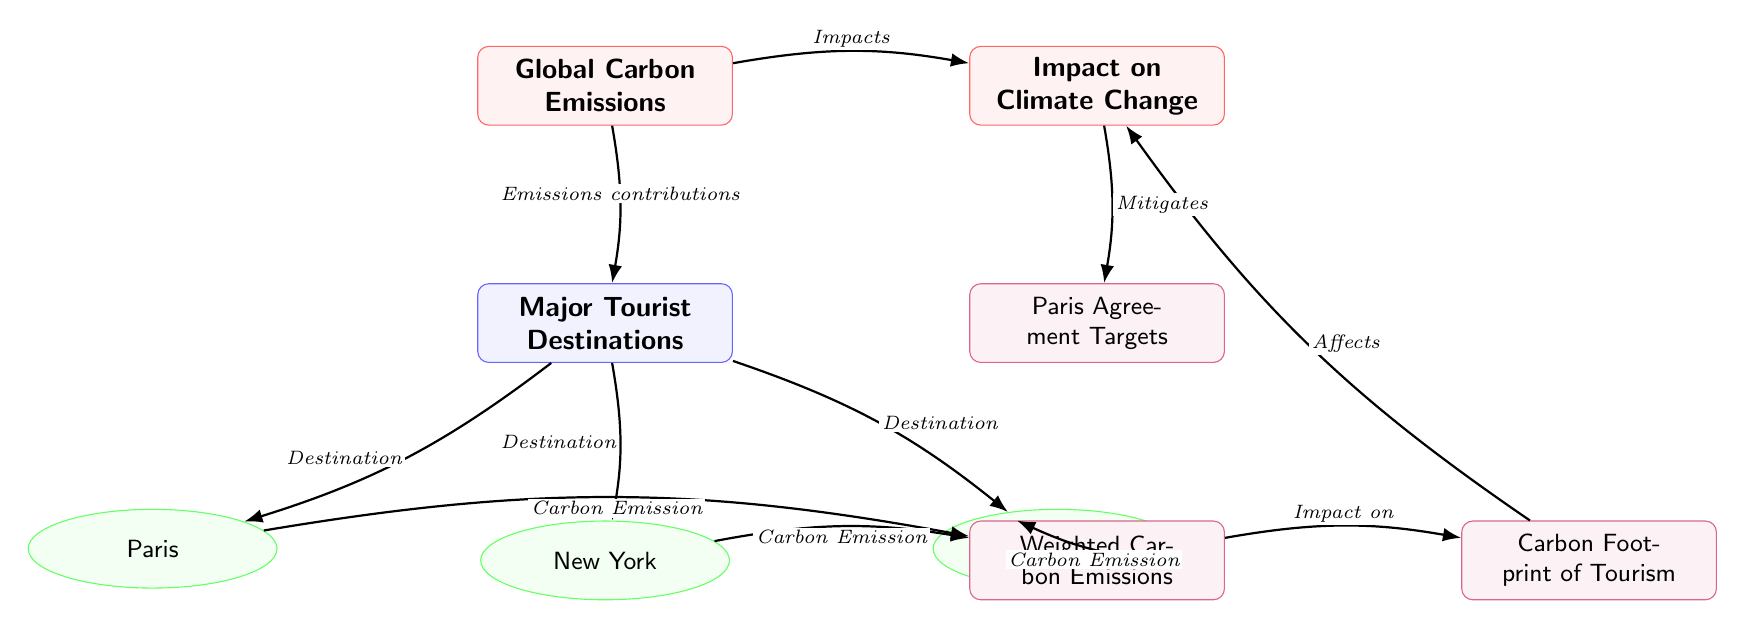What is the main concept represented in the diagram? The diagram features "Global Carbon Emissions" as its main concept, indicated by the rectangular node at the top labeled as such.
Answer: Global Carbon Emissions How many major tourist destinations are depicted in the diagram? There are three major tourist destinations illustrated: Paris, New York, and Bangkok. These are represented as ellipse nodes connected to the major tourist destinations node.
Answer: 3 Which destination is linked to the "Weighted Carbon Emissions" sub-concept? The destination "Paris" is linked to the "Weighted Carbon Emissions", as indicated by the arrow connecting these two nodes in the diagram.
Answer: Paris What is the relationship between "Carbon Footprint of Tourism" and "Impact on Climate Change"? The "Carbon Footprint of Tourism" influences the "Impact on Climate Change," as indicated by the arrow flowing from the "Carbon Footprint of Tourism" node to the "Impact on Climate Change" node.
Answer: Affects Which concept reduces the impact of climate change? The "Paris Agreement Targets" are shown to mitigate the impacts on climate change, positioned below the "Impact on Climate Change" node.
Answer: Paris Agreement Targets What type of relationship is depicted by the edge from "Major Tourist Destinations" to "Global Carbon Emissions"? The diagram shows a relationship indicated as "Emissions contributions" flowing from "Major Tourist Destinations" to "Global Carbon Emissions."
Answer: Emissions contributions What does the "Weighted Carbon Emissions" concept represent in the context of the destinations? "Weighted Carbon Emissions" represents the carbon emissions associated with each destination, based on the edges connecting it to the three tourist destinations.
Answer: Carbon Emission How does "Impact on Climate Change" connect to "Global Carbon Emissions"? The diagram shows a direct connection, labeled as "Impacts," linking "Global Carbon Emissions" to "Impact on Climate Change."
Answer: Impacts What is the significance of the node labeled "Impact on Climate Change"? This node represents the consequences that arise from the carbon emissions attributed to major tourist destinations, affecting the climate.
Answer: Consequences 